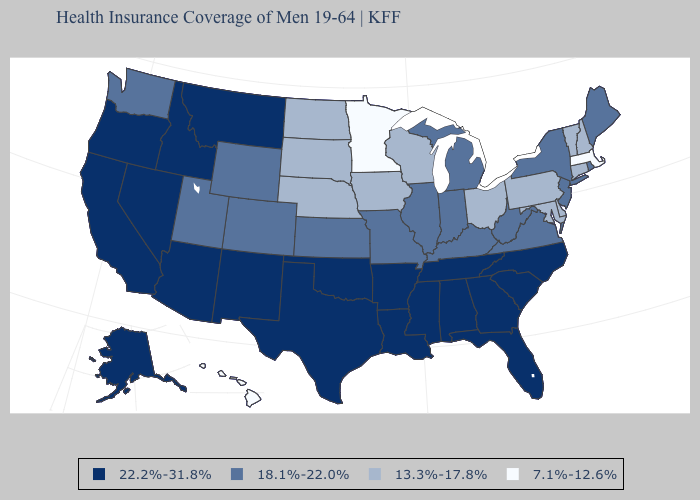Name the states that have a value in the range 13.3%-17.8%?
Write a very short answer. Connecticut, Delaware, Iowa, Maryland, Nebraska, New Hampshire, North Dakota, Ohio, Pennsylvania, South Dakota, Vermont, Wisconsin. What is the highest value in states that border Delaware?
Give a very brief answer. 18.1%-22.0%. Among the states that border New Hampshire , which have the lowest value?
Write a very short answer. Massachusetts. Does Missouri have a higher value than Utah?
Quick response, please. No. Name the states that have a value in the range 22.2%-31.8%?
Answer briefly. Alabama, Alaska, Arizona, Arkansas, California, Florida, Georgia, Idaho, Louisiana, Mississippi, Montana, Nevada, New Mexico, North Carolina, Oklahoma, Oregon, South Carolina, Tennessee, Texas. Name the states that have a value in the range 22.2%-31.8%?
Write a very short answer. Alabama, Alaska, Arizona, Arkansas, California, Florida, Georgia, Idaho, Louisiana, Mississippi, Montana, Nevada, New Mexico, North Carolina, Oklahoma, Oregon, South Carolina, Tennessee, Texas. What is the value of Oregon?
Quick response, please. 22.2%-31.8%. What is the value of Maine?
Quick response, please. 18.1%-22.0%. Does Oklahoma have a higher value than Oregon?
Short answer required. No. Does Kentucky have the lowest value in the South?
Write a very short answer. No. Does Louisiana have a lower value than Minnesota?
Answer briefly. No. What is the value of Hawaii?
Short answer required. 7.1%-12.6%. Among the states that border Indiana , does Michigan have the lowest value?
Concise answer only. No. Which states hav the highest value in the West?
Write a very short answer. Alaska, Arizona, California, Idaho, Montana, Nevada, New Mexico, Oregon. Name the states that have a value in the range 13.3%-17.8%?
Short answer required. Connecticut, Delaware, Iowa, Maryland, Nebraska, New Hampshire, North Dakota, Ohio, Pennsylvania, South Dakota, Vermont, Wisconsin. 